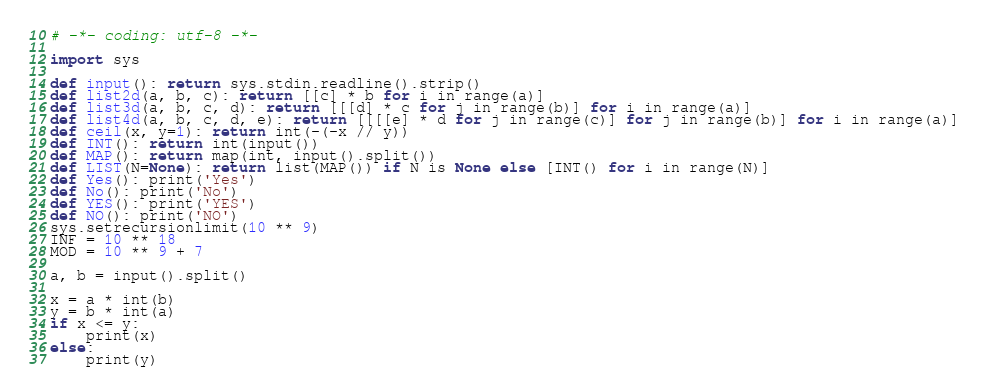Convert code to text. <code><loc_0><loc_0><loc_500><loc_500><_Python_># -*- coding: utf-8 -*-

import sys

def input(): return sys.stdin.readline().strip()
def list2d(a, b, c): return [[c] * b for i in range(a)]
def list3d(a, b, c, d): return [[[d] * c for j in range(b)] for i in range(a)]
def list4d(a, b, c, d, e): return [[[[e] * d for j in range(c)] for j in range(b)] for i in range(a)]
def ceil(x, y=1): return int(-(-x // y))
def INT(): return int(input())
def MAP(): return map(int, input().split())
def LIST(N=None): return list(MAP()) if N is None else [INT() for i in range(N)]
def Yes(): print('Yes')
def No(): print('No')
def YES(): print('YES')
def NO(): print('NO')
sys.setrecursionlimit(10 ** 9)
INF = 10 ** 18
MOD = 10 ** 9 + 7

a, b = input().split()

x = a * int(b)
y = b * int(a)
if x <= y:
    print(x)
else:
    print(y)
</code> 